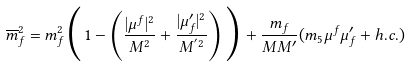<formula> <loc_0><loc_0><loc_500><loc_500>\overline { m } _ { f } ^ { 2 } = m _ { f } ^ { 2 } \Big { ( } 1 - \left ( \frac { | \mu ^ { f } | ^ { 2 } } { M ^ { 2 } } + \frac { | \mu ^ { \prime } _ { f } | ^ { 2 } } { M ^ { ^ { \prime } 2 } } \right ) \Big { ) } + \frac { m _ { f } } { M M ^ { \prime } } ( m _ { 5 } \mu ^ { f } \mu ^ { \prime } _ { f } + h . c . )</formula> 